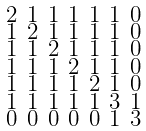Convert formula to latex. <formula><loc_0><loc_0><loc_500><loc_500>\begin{smallmatrix} 2 & 1 & 1 & 1 & 1 & 1 & 0 \\ 1 & 2 & 1 & 1 & 1 & 1 & 0 \\ 1 & 1 & 2 & 1 & 1 & 1 & 0 \\ 1 & 1 & 1 & 2 & 1 & 1 & 0 \\ 1 & 1 & 1 & 1 & 2 & 1 & 0 \\ 1 & 1 & 1 & 1 & 1 & 3 & 1 \\ 0 & 0 & 0 & 0 & 0 & 1 & 3 \end{smallmatrix}</formula> 